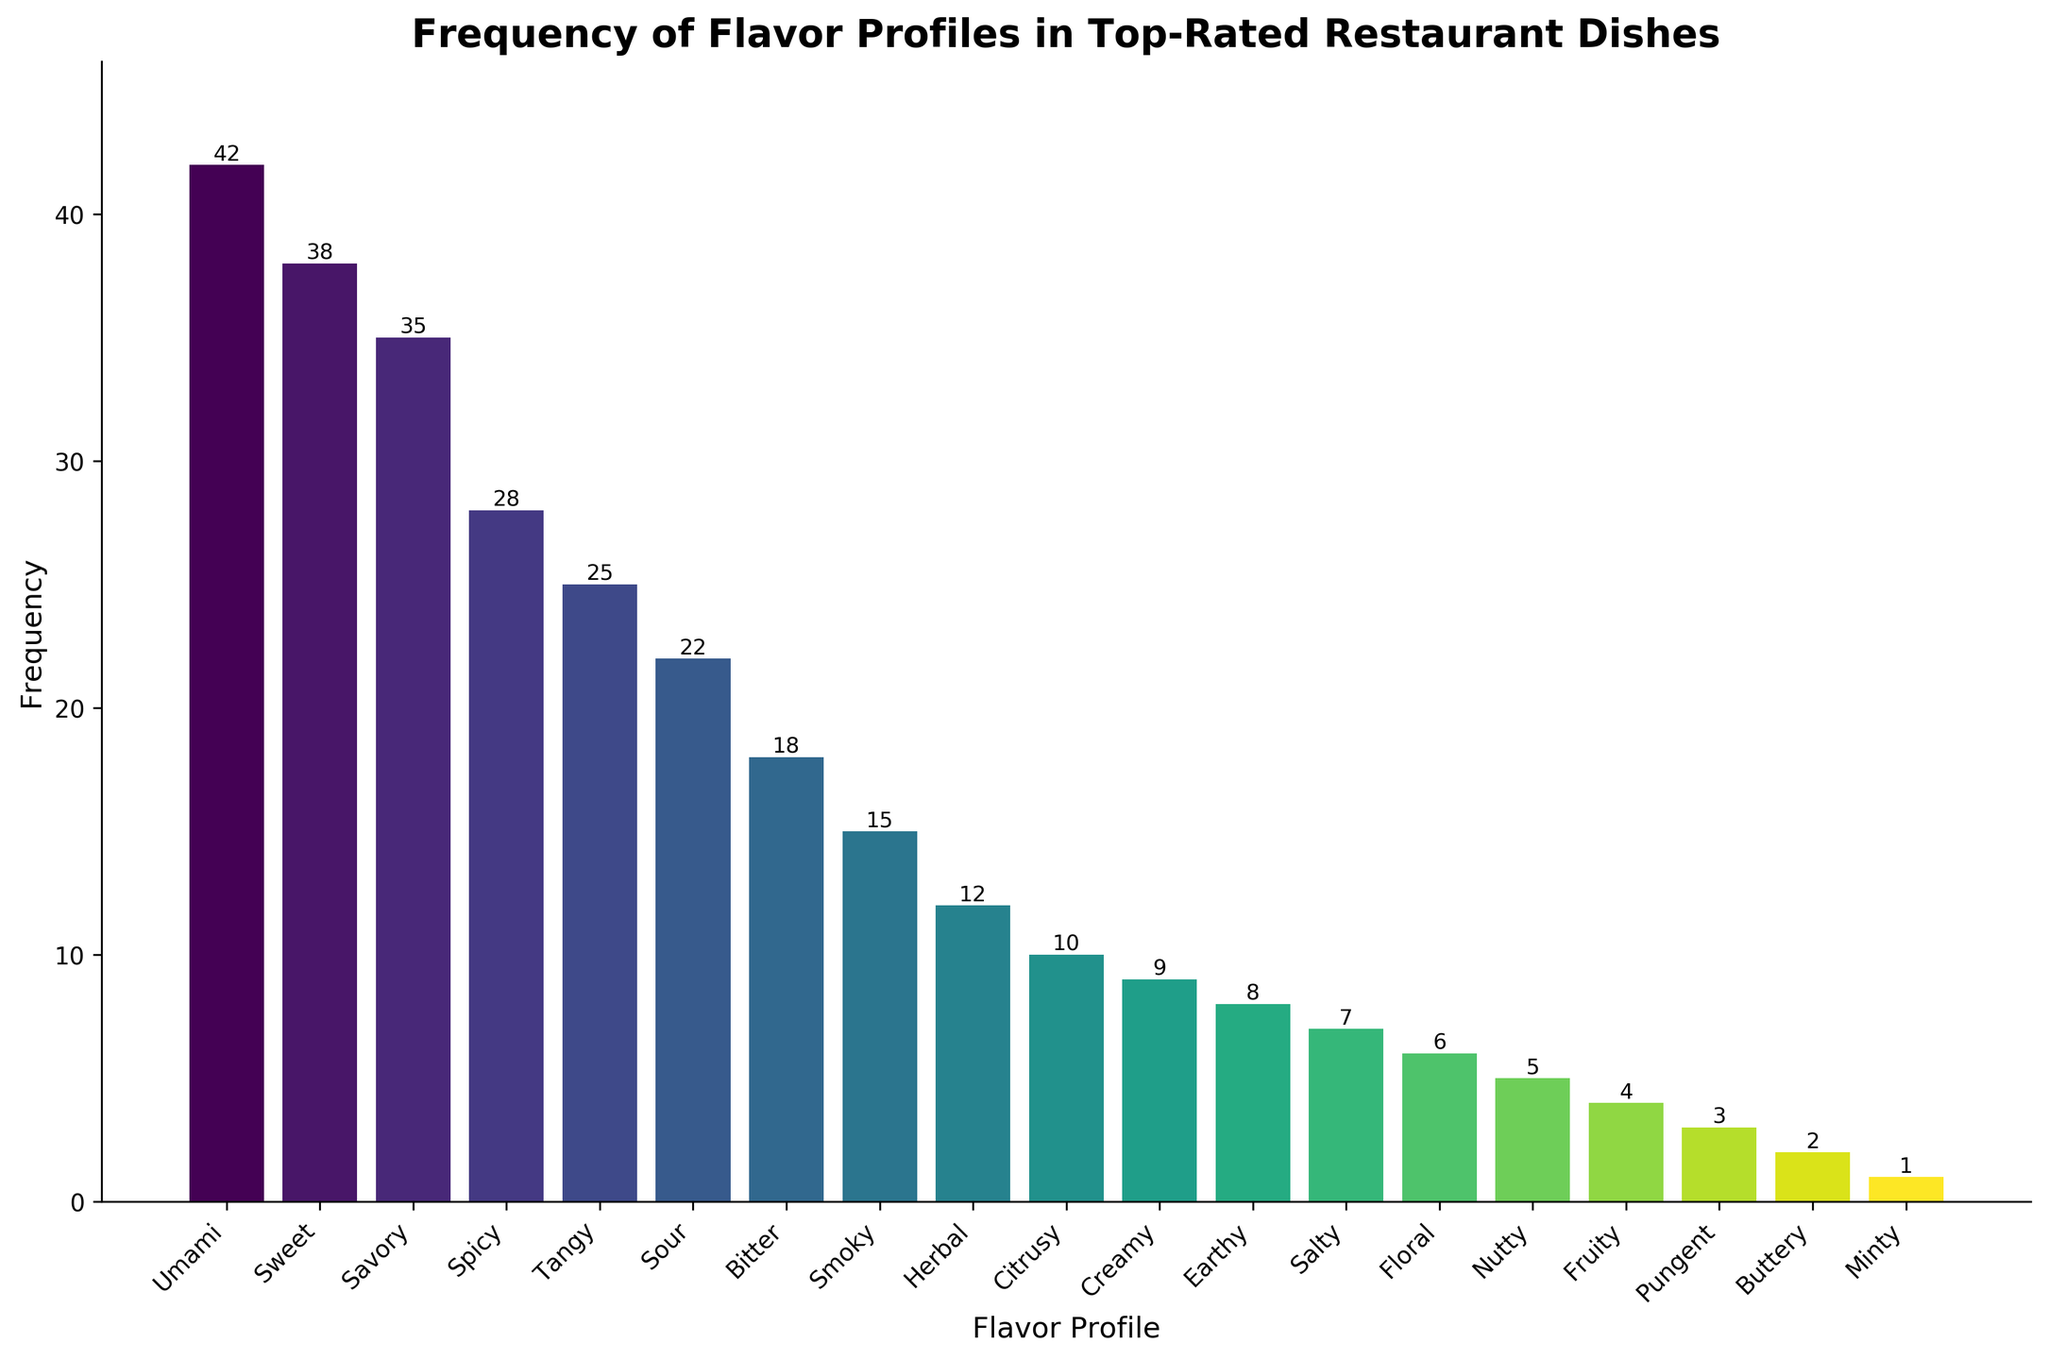What are the top three most frequent flavor profiles? To find the top three, sort the flavors by their frequencies in descending order. The highest frequencies are 42 for Umami, 38 for Sweet, and 35 for Savory.
Answer: Umami, Sweet, Savory Which flavor profile is the least frequent? Look for the flavor profile with the lowest frequency bar. The shortest bar corresponds to the frequency of 1, which is Minty.
Answer: Minty How many more top-rated dishes feature Umami compared to Smoky? Find the frequency of Umami (42) and subtract the frequency of Smoky (15) to get the difference. 42 - 15 = 27.
Answer: 27 Are there more dishes with a Sweet flavor profile than with a Spicy flavor profile? Compare the frequencies of Sweet (38) and Spicy (28). Since 38 is greater than 28, there are more Sweet dishes than Spicy.
Answer: Yes What is the cumulative frequency of Sweet, Savory, and Spicy flavor profiles? Add the frequencies of Sweet (38), Savory (35), and Spicy (28). 38 + 35 + 28 = 101.
Answer: 101 Which flavor profiles have frequencies greater than 30? Identify the flavor profiles whose bars exceed the height corresponding to the frequency of 30. These are Umami (42), Sweet (38), and Savory (35).
Answer: Umami, Sweet, Savory What is the difference in frequency between Herbal and Citrusy flavor profiles? Find the difference by subtracting the frequency of Citrusy (10) from the frequency of Herbal (12). 12 - 10 = 2.
Answer: 2 Which color does the bar representing the Nutty flavor profile have? The Nutty flavor profile has a frequency of 5. Observe the bar corresponding to frequency 5 and note its color, which is likely a shade of green, as the color gradient is in viridis colors.
Answer: Green Summing the frequencies of all flavor profiles below a frequency of 10, what is the total? Add the frequencies of Creamy (9), Earthy (8), Salty (7), Floral (6), Nutty (5), Fruity (4), Pungent (3), Buttery (2), and Minty (1). 9 + 8 + 7 + 6 + 5 + 4 + 3 + 2 + 1 = 45.
Answer: 45 Are there more than 5 flavor profiles with a frequency of fewer than 10? Count the number of flavor profiles with frequencies below 10. These are Creamy (9), Earthy (8), Salty (7), Floral (6), Nutty (5), Fruity (4), Pungent (3), Buttery (2), and Minty (1), which totals 9.
Answer: Yes, 9 